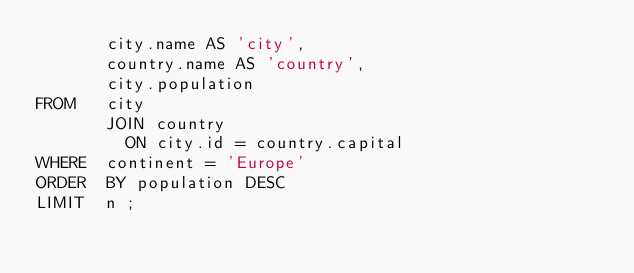Convert code to text. <code><loc_0><loc_0><loc_500><loc_500><_SQL_>       city.name AS 'city',
       country.name AS 'country',
       city.population
FROM   city
       JOIN country
         ON city.id = country.capital
WHERE  continent = 'Europe'
ORDER  BY population DESC
LIMIT  n ;</code> 